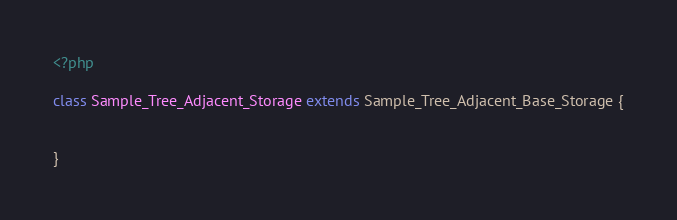Convert code to text. <code><loc_0><loc_0><loc_500><loc_500><_PHP_><?php

class Sample_Tree_Adjacent_Storage extends Sample_Tree_Adjacent_Base_Storage {
  

}
</code> 